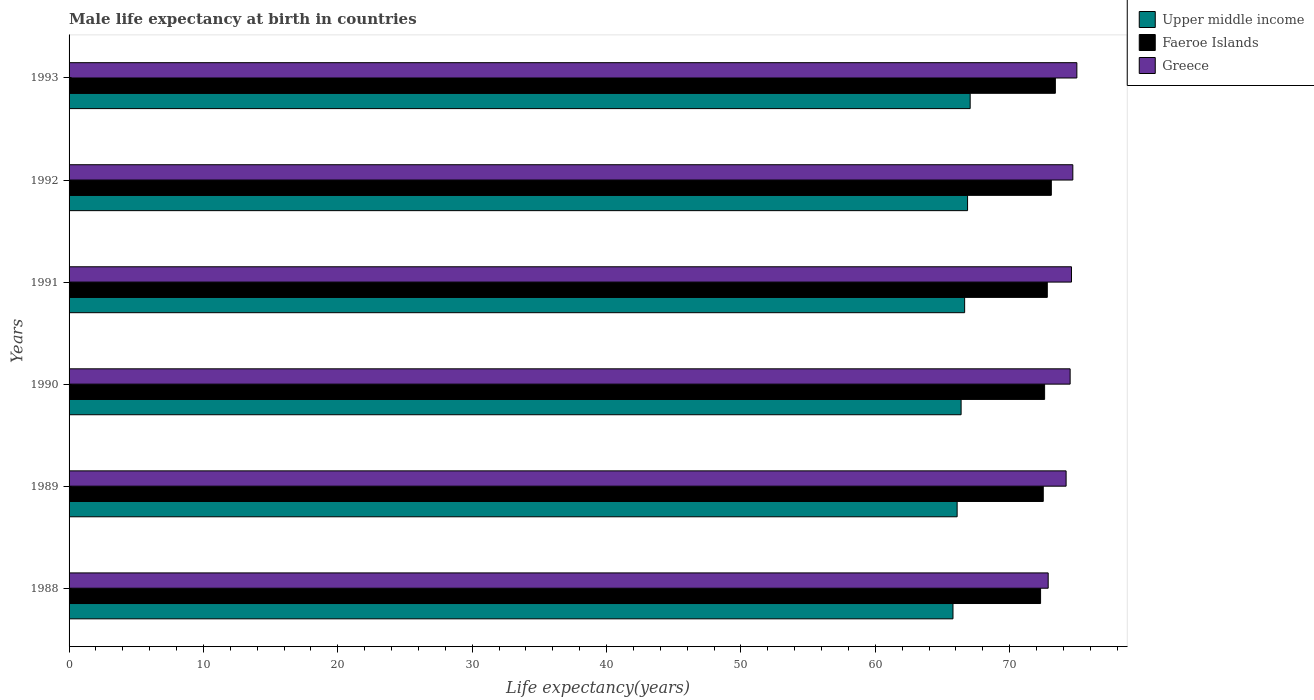Are the number of bars on each tick of the Y-axis equal?
Make the answer very short. Yes. What is the label of the 5th group of bars from the top?
Give a very brief answer. 1989. In how many cases, is the number of bars for a given year not equal to the number of legend labels?
Your response must be concise. 0. What is the male life expectancy at birth in Faeroe Islands in 1991?
Make the answer very short. 72.8. Across all years, what is the maximum male life expectancy at birth in Faeroe Islands?
Your answer should be compact. 73.4. Across all years, what is the minimum male life expectancy at birth in Faeroe Islands?
Your answer should be very brief. 72.3. In which year was the male life expectancy at birth in Upper middle income maximum?
Give a very brief answer. 1993. What is the total male life expectancy at birth in Upper middle income in the graph?
Provide a short and direct response. 398.83. What is the difference between the male life expectancy at birth in Faeroe Islands in 1990 and that in 1991?
Your response must be concise. -0.2. What is the difference between the male life expectancy at birth in Upper middle income in 1992 and the male life expectancy at birth in Greece in 1989?
Ensure brevity in your answer.  -7.33. What is the average male life expectancy at birth in Faeroe Islands per year?
Provide a short and direct response. 72.78. In the year 1993, what is the difference between the male life expectancy at birth in Faeroe Islands and male life expectancy at birth in Upper middle income?
Ensure brevity in your answer.  6.34. What is the ratio of the male life expectancy at birth in Greece in 1990 to that in 1993?
Keep it short and to the point. 0.99. Is the male life expectancy at birth in Greece in 1990 less than that in 1993?
Your answer should be very brief. Yes. What is the difference between the highest and the second highest male life expectancy at birth in Faeroe Islands?
Make the answer very short. 0.3. What is the difference between the highest and the lowest male life expectancy at birth in Upper middle income?
Offer a very short reply. 1.28. What does the 3rd bar from the top in 1989 represents?
Your answer should be compact. Upper middle income. What does the 3rd bar from the bottom in 1993 represents?
Keep it short and to the point. Greece. Is it the case that in every year, the sum of the male life expectancy at birth in Upper middle income and male life expectancy at birth in Greece is greater than the male life expectancy at birth in Faeroe Islands?
Ensure brevity in your answer.  Yes. How many bars are there?
Provide a succinct answer. 18. Are the values on the major ticks of X-axis written in scientific E-notation?
Your response must be concise. No. Does the graph contain grids?
Provide a short and direct response. No. How are the legend labels stacked?
Keep it short and to the point. Vertical. What is the title of the graph?
Give a very brief answer. Male life expectancy at birth in countries. Does "Guinea-Bissau" appear as one of the legend labels in the graph?
Ensure brevity in your answer.  No. What is the label or title of the X-axis?
Your answer should be compact. Life expectancy(years). What is the Life expectancy(years) in Upper middle income in 1988?
Ensure brevity in your answer.  65.78. What is the Life expectancy(years) of Faeroe Islands in 1988?
Give a very brief answer. 72.3. What is the Life expectancy(years) of Greece in 1988?
Your response must be concise. 72.87. What is the Life expectancy(years) in Upper middle income in 1989?
Ensure brevity in your answer.  66.09. What is the Life expectancy(years) of Faeroe Islands in 1989?
Provide a succinct answer. 72.5. What is the Life expectancy(years) of Greece in 1989?
Your answer should be very brief. 74.2. What is the Life expectancy(years) in Upper middle income in 1990?
Give a very brief answer. 66.39. What is the Life expectancy(years) in Faeroe Islands in 1990?
Your answer should be very brief. 72.6. What is the Life expectancy(years) of Greece in 1990?
Make the answer very short. 74.5. What is the Life expectancy(years) of Upper middle income in 1991?
Ensure brevity in your answer.  66.65. What is the Life expectancy(years) in Faeroe Islands in 1991?
Your response must be concise. 72.8. What is the Life expectancy(years) in Greece in 1991?
Your response must be concise. 74.6. What is the Life expectancy(years) in Upper middle income in 1992?
Provide a succinct answer. 66.87. What is the Life expectancy(years) in Faeroe Islands in 1992?
Your answer should be very brief. 73.1. What is the Life expectancy(years) in Greece in 1992?
Give a very brief answer. 74.7. What is the Life expectancy(years) in Upper middle income in 1993?
Your answer should be very brief. 67.06. What is the Life expectancy(years) in Faeroe Islands in 1993?
Provide a short and direct response. 73.4. Across all years, what is the maximum Life expectancy(years) of Upper middle income?
Your response must be concise. 67.06. Across all years, what is the maximum Life expectancy(years) of Faeroe Islands?
Your response must be concise. 73.4. Across all years, what is the maximum Life expectancy(years) of Greece?
Your answer should be very brief. 75. Across all years, what is the minimum Life expectancy(years) of Upper middle income?
Keep it short and to the point. 65.78. Across all years, what is the minimum Life expectancy(years) of Faeroe Islands?
Your response must be concise. 72.3. Across all years, what is the minimum Life expectancy(years) of Greece?
Ensure brevity in your answer.  72.87. What is the total Life expectancy(years) of Upper middle income in the graph?
Offer a terse response. 398.83. What is the total Life expectancy(years) in Faeroe Islands in the graph?
Your answer should be compact. 436.7. What is the total Life expectancy(years) of Greece in the graph?
Offer a very short reply. 445.87. What is the difference between the Life expectancy(years) in Upper middle income in 1988 and that in 1989?
Provide a succinct answer. -0.31. What is the difference between the Life expectancy(years) in Faeroe Islands in 1988 and that in 1989?
Keep it short and to the point. -0.2. What is the difference between the Life expectancy(years) in Greece in 1988 and that in 1989?
Offer a terse response. -1.33. What is the difference between the Life expectancy(years) of Upper middle income in 1988 and that in 1990?
Your answer should be compact. -0.6. What is the difference between the Life expectancy(years) of Faeroe Islands in 1988 and that in 1990?
Keep it short and to the point. -0.3. What is the difference between the Life expectancy(years) in Greece in 1988 and that in 1990?
Make the answer very short. -1.63. What is the difference between the Life expectancy(years) in Upper middle income in 1988 and that in 1991?
Keep it short and to the point. -0.87. What is the difference between the Life expectancy(years) in Greece in 1988 and that in 1991?
Provide a succinct answer. -1.73. What is the difference between the Life expectancy(years) of Upper middle income in 1988 and that in 1992?
Keep it short and to the point. -1.08. What is the difference between the Life expectancy(years) in Faeroe Islands in 1988 and that in 1992?
Give a very brief answer. -0.8. What is the difference between the Life expectancy(years) in Greece in 1988 and that in 1992?
Ensure brevity in your answer.  -1.83. What is the difference between the Life expectancy(years) in Upper middle income in 1988 and that in 1993?
Your answer should be compact. -1.28. What is the difference between the Life expectancy(years) of Faeroe Islands in 1988 and that in 1993?
Ensure brevity in your answer.  -1.1. What is the difference between the Life expectancy(years) in Greece in 1988 and that in 1993?
Keep it short and to the point. -2.13. What is the difference between the Life expectancy(years) in Upper middle income in 1989 and that in 1990?
Ensure brevity in your answer.  -0.3. What is the difference between the Life expectancy(years) in Greece in 1989 and that in 1990?
Give a very brief answer. -0.3. What is the difference between the Life expectancy(years) of Upper middle income in 1989 and that in 1991?
Give a very brief answer. -0.56. What is the difference between the Life expectancy(years) of Faeroe Islands in 1989 and that in 1991?
Give a very brief answer. -0.3. What is the difference between the Life expectancy(years) in Upper middle income in 1989 and that in 1992?
Offer a terse response. -0.78. What is the difference between the Life expectancy(years) of Faeroe Islands in 1989 and that in 1992?
Your answer should be compact. -0.6. What is the difference between the Life expectancy(years) in Upper middle income in 1989 and that in 1993?
Make the answer very short. -0.97. What is the difference between the Life expectancy(years) in Faeroe Islands in 1989 and that in 1993?
Provide a short and direct response. -0.9. What is the difference between the Life expectancy(years) of Greece in 1989 and that in 1993?
Your answer should be very brief. -0.8. What is the difference between the Life expectancy(years) of Upper middle income in 1990 and that in 1991?
Your answer should be compact. -0.26. What is the difference between the Life expectancy(years) in Faeroe Islands in 1990 and that in 1991?
Your response must be concise. -0.2. What is the difference between the Life expectancy(years) in Greece in 1990 and that in 1991?
Your answer should be compact. -0.1. What is the difference between the Life expectancy(years) of Upper middle income in 1990 and that in 1992?
Keep it short and to the point. -0.48. What is the difference between the Life expectancy(years) in Faeroe Islands in 1990 and that in 1992?
Your answer should be very brief. -0.5. What is the difference between the Life expectancy(years) in Greece in 1990 and that in 1992?
Offer a terse response. -0.2. What is the difference between the Life expectancy(years) in Upper middle income in 1990 and that in 1993?
Provide a succinct answer. -0.67. What is the difference between the Life expectancy(years) in Greece in 1990 and that in 1993?
Give a very brief answer. -0.5. What is the difference between the Life expectancy(years) of Upper middle income in 1991 and that in 1992?
Your answer should be compact. -0.22. What is the difference between the Life expectancy(years) of Faeroe Islands in 1991 and that in 1992?
Your answer should be very brief. -0.3. What is the difference between the Life expectancy(years) in Greece in 1991 and that in 1992?
Your response must be concise. -0.1. What is the difference between the Life expectancy(years) in Upper middle income in 1991 and that in 1993?
Your answer should be compact. -0.41. What is the difference between the Life expectancy(years) in Greece in 1991 and that in 1993?
Your answer should be very brief. -0.4. What is the difference between the Life expectancy(years) of Upper middle income in 1992 and that in 1993?
Ensure brevity in your answer.  -0.19. What is the difference between the Life expectancy(years) of Upper middle income in 1988 and the Life expectancy(years) of Faeroe Islands in 1989?
Offer a terse response. -6.72. What is the difference between the Life expectancy(years) of Upper middle income in 1988 and the Life expectancy(years) of Greece in 1989?
Your response must be concise. -8.42. What is the difference between the Life expectancy(years) of Upper middle income in 1988 and the Life expectancy(years) of Faeroe Islands in 1990?
Your response must be concise. -6.82. What is the difference between the Life expectancy(years) of Upper middle income in 1988 and the Life expectancy(years) of Greece in 1990?
Provide a short and direct response. -8.72. What is the difference between the Life expectancy(years) of Upper middle income in 1988 and the Life expectancy(years) of Faeroe Islands in 1991?
Your response must be concise. -7.02. What is the difference between the Life expectancy(years) of Upper middle income in 1988 and the Life expectancy(years) of Greece in 1991?
Keep it short and to the point. -8.82. What is the difference between the Life expectancy(years) of Upper middle income in 1988 and the Life expectancy(years) of Faeroe Islands in 1992?
Offer a terse response. -7.32. What is the difference between the Life expectancy(years) in Upper middle income in 1988 and the Life expectancy(years) in Greece in 1992?
Your answer should be very brief. -8.92. What is the difference between the Life expectancy(years) in Upper middle income in 1988 and the Life expectancy(years) in Faeroe Islands in 1993?
Make the answer very short. -7.62. What is the difference between the Life expectancy(years) of Upper middle income in 1988 and the Life expectancy(years) of Greece in 1993?
Make the answer very short. -9.22. What is the difference between the Life expectancy(years) in Faeroe Islands in 1988 and the Life expectancy(years) in Greece in 1993?
Give a very brief answer. -2.7. What is the difference between the Life expectancy(years) of Upper middle income in 1989 and the Life expectancy(years) of Faeroe Islands in 1990?
Ensure brevity in your answer.  -6.51. What is the difference between the Life expectancy(years) in Upper middle income in 1989 and the Life expectancy(years) in Greece in 1990?
Offer a terse response. -8.41. What is the difference between the Life expectancy(years) of Upper middle income in 1989 and the Life expectancy(years) of Faeroe Islands in 1991?
Ensure brevity in your answer.  -6.71. What is the difference between the Life expectancy(years) in Upper middle income in 1989 and the Life expectancy(years) in Greece in 1991?
Your answer should be very brief. -8.51. What is the difference between the Life expectancy(years) of Upper middle income in 1989 and the Life expectancy(years) of Faeroe Islands in 1992?
Keep it short and to the point. -7.01. What is the difference between the Life expectancy(years) in Upper middle income in 1989 and the Life expectancy(years) in Greece in 1992?
Keep it short and to the point. -8.61. What is the difference between the Life expectancy(years) of Upper middle income in 1989 and the Life expectancy(years) of Faeroe Islands in 1993?
Provide a succinct answer. -7.31. What is the difference between the Life expectancy(years) of Upper middle income in 1989 and the Life expectancy(years) of Greece in 1993?
Provide a short and direct response. -8.91. What is the difference between the Life expectancy(years) in Upper middle income in 1990 and the Life expectancy(years) in Faeroe Islands in 1991?
Give a very brief answer. -6.41. What is the difference between the Life expectancy(years) in Upper middle income in 1990 and the Life expectancy(years) in Greece in 1991?
Provide a short and direct response. -8.21. What is the difference between the Life expectancy(years) in Upper middle income in 1990 and the Life expectancy(years) in Faeroe Islands in 1992?
Offer a terse response. -6.71. What is the difference between the Life expectancy(years) in Upper middle income in 1990 and the Life expectancy(years) in Greece in 1992?
Your answer should be compact. -8.31. What is the difference between the Life expectancy(years) in Faeroe Islands in 1990 and the Life expectancy(years) in Greece in 1992?
Keep it short and to the point. -2.1. What is the difference between the Life expectancy(years) in Upper middle income in 1990 and the Life expectancy(years) in Faeroe Islands in 1993?
Ensure brevity in your answer.  -7.01. What is the difference between the Life expectancy(years) in Upper middle income in 1990 and the Life expectancy(years) in Greece in 1993?
Your response must be concise. -8.61. What is the difference between the Life expectancy(years) in Upper middle income in 1991 and the Life expectancy(years) in Faeroe Islands in 1992?
Your answer should be compact. -6.45. What is the difference between the Life expectancy(years) of Upper middle income in 1991 and the Life expectancy(years) of Greece in 1992?
Ensure brevity in your answer.  -8.05. What is the difference between the Life expectancy(years) in Upper middle income in 1991 and the Life expectancy(years) in Faeroe Islands in 1993?
Offer a very short reply. -6.75. What is the difference between the Life expectancy(years) in Upper middle income in 1991 and the Life expectancy(years) in Greece in 1993?
Provide a succinct answer. -8.35. What is the difference between the Life expectancy(years) in Faeroe Islands in 1991 and the Life expectancy(years) in Greece in 1993?
Your answer should be very brief. -2.2. What is the difference between the Life expectancy(years) in Upper middle income in 1992 and the Life expectancy(years) in Faeroe Islands in 1993?
Provide a short and direct response. -6.53. What is the difference between the Life expectancy(years) of Upper middle income in 1992 and the Life expectancy(years) of Greece in 1993?
Make the answer very short. -8.13. What is the difference between the Life expectancy(years) of Faeroe Islands in 1992 and the Life expectancy(years) of Greece in 1993?
Offer a very short reply. -1.9. What is the average Life expectancy(years) in Upper middle income per year?
Keep it short and to the point. 66.47. What is the average Life expectancy(years) of Faeroe Islands per year?
Provide a succinct answer. 72.78. What is the average Life expectancy(years) of Greece per year?
Offer a terse response. 74.31. In the year 1988, what is the difference between the Life expectancy(years) in Upper middle income and Life expectancy(years) in Faeroe Islands?
Keep it short and to the point. -6.52. In the year 1988, what is the difference between the Life expectancy(years) in Upper middle income and Life expectancy(years) in Greece?
Make the answer very short. -7.09. In the year 1988, what is the difference between the Life expectancy(years) in Faeroe Islands and Life expectancy(years) in Greece?
Keep it short and to the point. -0.57. In the year 1989, what is the difference between the Life expectancy(years) of Upper middle income and Life expectancy(years) of Faeroe Islands?
Provide a succinct answer. -6.41. In the year 1989, what is the difference between the Life expectancy(years) in Upper middle income and Life expectancy(years) in Greece?
Make the answer very short. -8.11. In the year 1989, what is the difference between the Life expectancy(years) of Faeroe Islands and Life expectancy(years) of Greece?
Provide a short and direct response. -1.7. In the year 1990, what is the difference between the Life expectancy(years) in Upper middle income and Life expectancy(years) in Faeroe Islands?
Give a very brief answer. -6.21. In the year 1990, what is the difference between the Life expectancy(years) in Upper middle income and Life expectancy(years) in Greece?
Your answer should be very brief. -8.11. In the year 1991, what is the difference between the Life expectancy(years) in Upper middle income and Life expectancy(years) in Faeroe Islands?
Keep it short and to the point. -6.15. In the year 1991, what is the difference between the Life expectancy(years) of Upper middle income and Life expectancy(years) of Greece?
Give a very brief answer. -7.95. In the year 1992, what is the difference between the Life expectancy(years) in Upper middle income and Life expectancy(years) in Faeroe Islands?
Offer a terse response. -6.23. In the year 1992, what is the difference between the Life expectancy(years) in Upper middle income and Life expectancy(years) in Greece?
Provide a succinct answer. -7.83. In the year 1992, what is the difference between the Life expectancy(years) in Faeroe Islands and Life expectancy(years) in Greece?
Offer a terse response. -1.6. In the year 1993, what is the difference between the Life expectancy(years) of Upper middle income and Life expectancy(years) of Faeroe Islands?
Offer a very short reply. -6.34. In the year 1993, what is the difference between the Life expectancy(years) of Upper middle income and Life expectancy(years) of Greece?
Provide a succinct answer. -7.94. In the year 1993, what is the difference between the Life expectancy(years) of Faeroe Islands and Life expectancy(years) of Greece?
Offer a terse response. -1.6. What is the ratio of the Life expectancy(years) of Faeroe Islands in 1988 to that in 1989?
Keep it short and to the point. 1. What is the ratio of the Life expectancy(years) in Greece in 1988 to that in 1989?
Your answer should be very brief. 0.98. What is the ratio of the Life expectancy(years) in Upper middle income in 1988 to that in 1990?
Offer a terse response. 0.99. What is the ratio of the Life expectancy(years) in Faeroe Islands in 1988 to that in 1990?
Make the answer very short. 1. What is the ratio of the Life expectancy(years) in Greece in 1988 to that in 1990?
Your answer should be compact. 0.98. What is the ratio of the Life expectancy(years) of Upper middle income in 1988 to that in 1991?
Ensure brevity in your answer.  0.99. What is the ratio of the Life expectancy(years) in Faeroe Islands in 1988 to that in 1991?
Your response must be concise. 0.99. What is the ratio of the Life expectancy(years) in Greece in 1988 to that in 1991?
Offer a terse response. 0.98. What is the ratio of the Life expectancy(years) in Upper middle income in 1988 to that in 1992?
Make the answer very short. 0.98. What is the ratio of the Life expectancy(years) of Greece in 1988 to that in 1992?
Your answer should be compact. 0.98. What is the ratio of the Life expectancy(years) of Upper middle income in 1988 to that in 1993?
Offer a very short reply. 0.98. What is the ratio of the Life expectancy(years) in Greece in 1988 to that in 1993?
Your answer should be compact. 0.97. What is the ratio of the Life expectancy(years) of Faeroe Islands in 1989 to that in 1990?
Keep it short and to the point. 1. What is the ratio of the Life expectancy(years) of Upper middle income in 1989 to that in 1991?
Provide a short and direct response. 0.99. What is the ratio of the Life expectancy(years) of Greece in 1989 to that in 1991?
Give a very brief answer. 0.99. What is the ratio of the Life expectancy(years) in Upper middle income in 1989 to that in 1992?
Offer a very short reply. 0.99. What is the ratio of the Life expectancy(years) of Greece in 1989 to that in 1992?
Provide a short and direct response. 0.99. What is the ratio of the Life expectancy(years) of Upper middle income in 1989 to that in 1993?
Your response must be concise. 0.99. What is the ratio of the Life expectancy(years) of Greece in 1989 to that in 1993?
Provide a succinct answer. 0.99. What is the ratio of the Life expectancy(years) in Upper middle income in 1990 to that in 1992?
Keep it short and to the point. 0.99. What is the ratio of the Life expectancy(years) of Faeroe Islands in 1990 to that in 1993?
Offer a terse response. 0.99. What is the ratio of the Life expectancy(years) in Greece in 1990 to that in 1993?
Offer a terse response. 0.99. What is the ratio of the Life expectancy(years) of Faeroe Islands in 1991 to that in 1992?
Make the answer very short. 1. What is the ratio of the Life expectancy(years) in Upper middle income in 1991 to that in 1993?
Provide a succinct answer. 0.99. What is the ratio of the Life expectancy(years) of Faeroe Islands in 1991 to that in 1993?
Ensure brevity in your answer.  0.99. What is the ratio of the Life expectancy(years) in Greece in 1991 to that in 1993?
Your answer should be very brief. 0.99. What is the ratio of the Life expectancy(years) of Upper middle income in 1992 to that in 1993?
Your response must be concise. 1. What is the ratio of the Life expectancy(years) of Greece in 1992 to that in 1993?
Offer a terse response. 1. What is the difference between the highest and the second highest Life expectancy(years) of Upper middle income?
Provide a succinct answer. 0.19. What is the difference between the highest and the second highest Life expectancy(years) of Greece?
Provide a succinct answer. 0.3. What is the difference between the highest and the lowest Life expectancy(years) in Upper middle income?
Make the answer very short. 1.28. What is the difference between the highest and the lowest Life expectancy(years) of Faeroe Islands?
Your response must be concise. 1.1. What is the difference between the highest and the lowest Life expectancy(years) of Greece?
Your response must be concise. 2.13. 